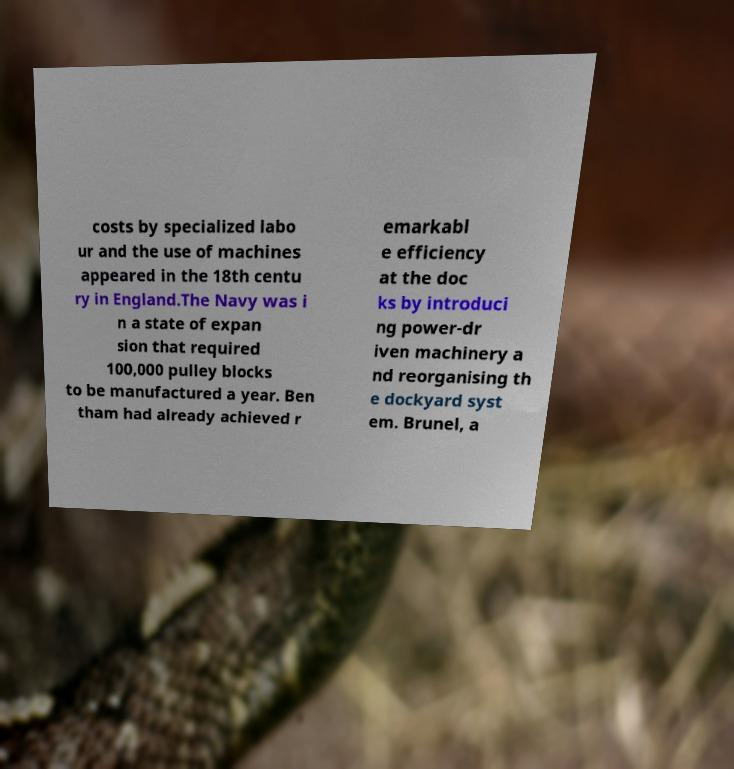For documentation purposes, I need the text within this image transcribed. Could you provide that? costs by specialized labo ur and the use of machines appeared in the 18th centu ry in England.The Navy was i n a state of expan sion that required 100,000 pulley blocks to be manufactured a year. Ben tham had already achieved r emarkabl e efficiency at the doc ks by introduci ng power-dr iven machinery a nd reorganising th e dockyard syst em. Brunel, a 